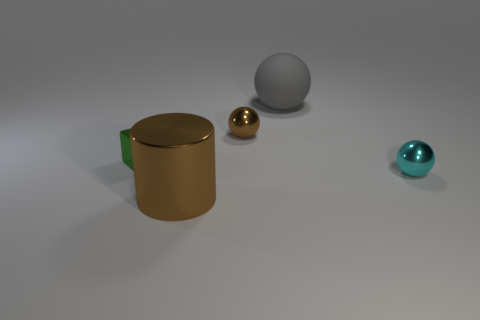Is there anything else that has the same material as the gray object?
Give a very brief answer. No. What number of cyan objects are there?
Provide a succinct answer. 1. There is a metal object that is in front of the small sphere that is on the right side of the brown metallic thing that is behind the small green metal thing; what color is it?
Offer a very short reply. Brown. Is the number of cyan things less than the number of small gray matte cubes?
Provide a succinct answer. No. The other metal object that is the same shape as the cyan shiny object is what color?
Give a very brief answer. Brown. The big cylinder that is the same material as the tiny cyan object is what color?
Offer a very short reply. Brown. What number of gray matte cylinders are the same size as the brown sphere?
Provide a succinct answer. 0. What is the material of the cube?
Make the answer very short. Metal. Is the number of tiny green objects greater than the number of small purple metallic cylinders?
Give a very brief answer. Yes. Is the cyan object the same shape as the big brown object?
Make the answer very short. No. 